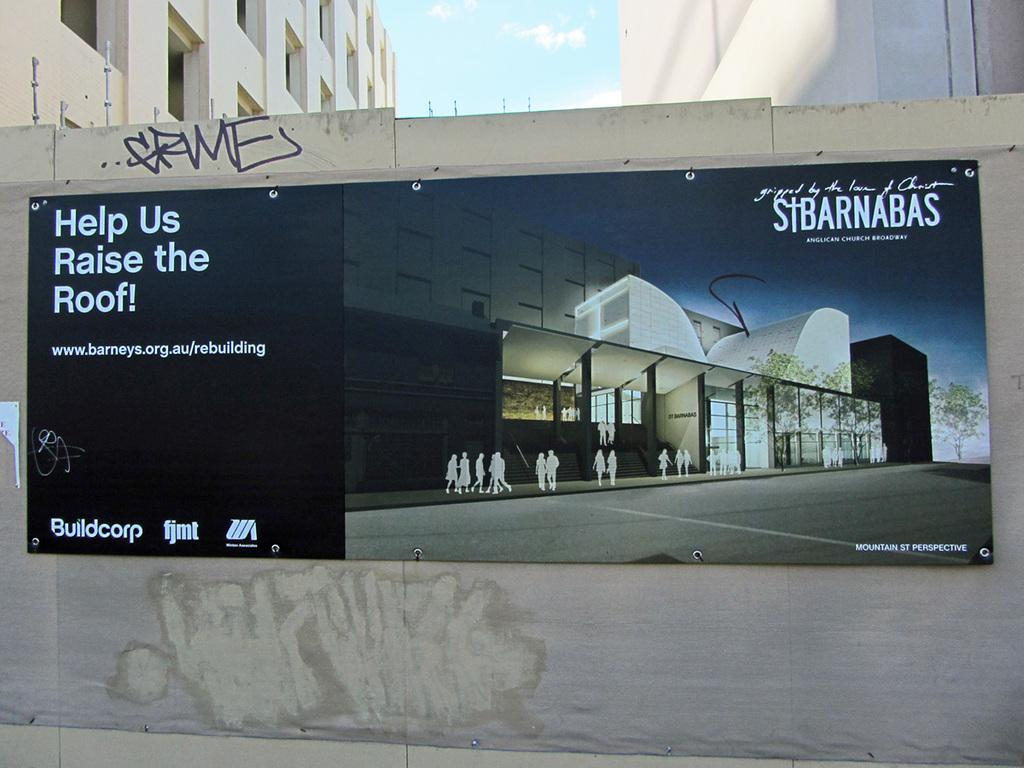<image>
Summarize the visual content of the image. A St. Barnabas advertisement includes a rallying cry to raise the roof. 